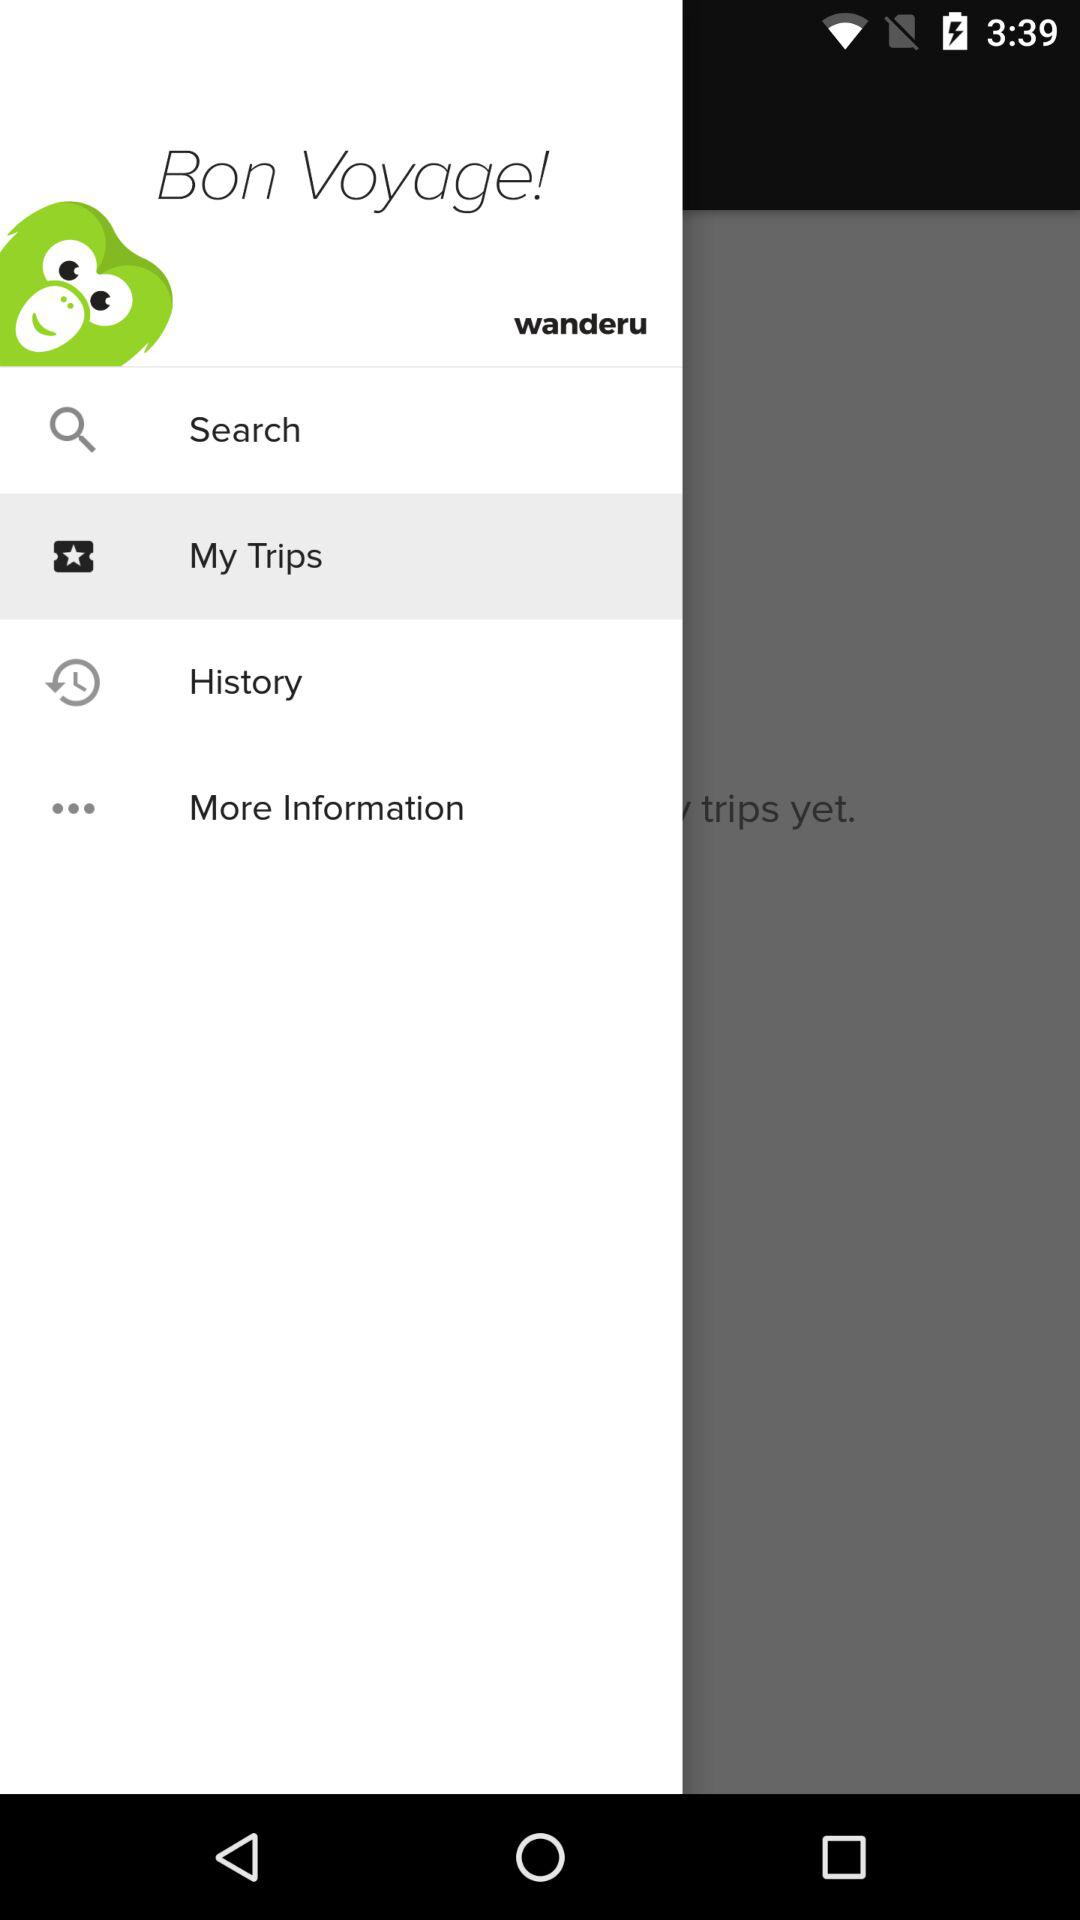How many notifications are there in "My Trips"?
When the provided information is insufficient, respond with <no answer>. <no answer> 